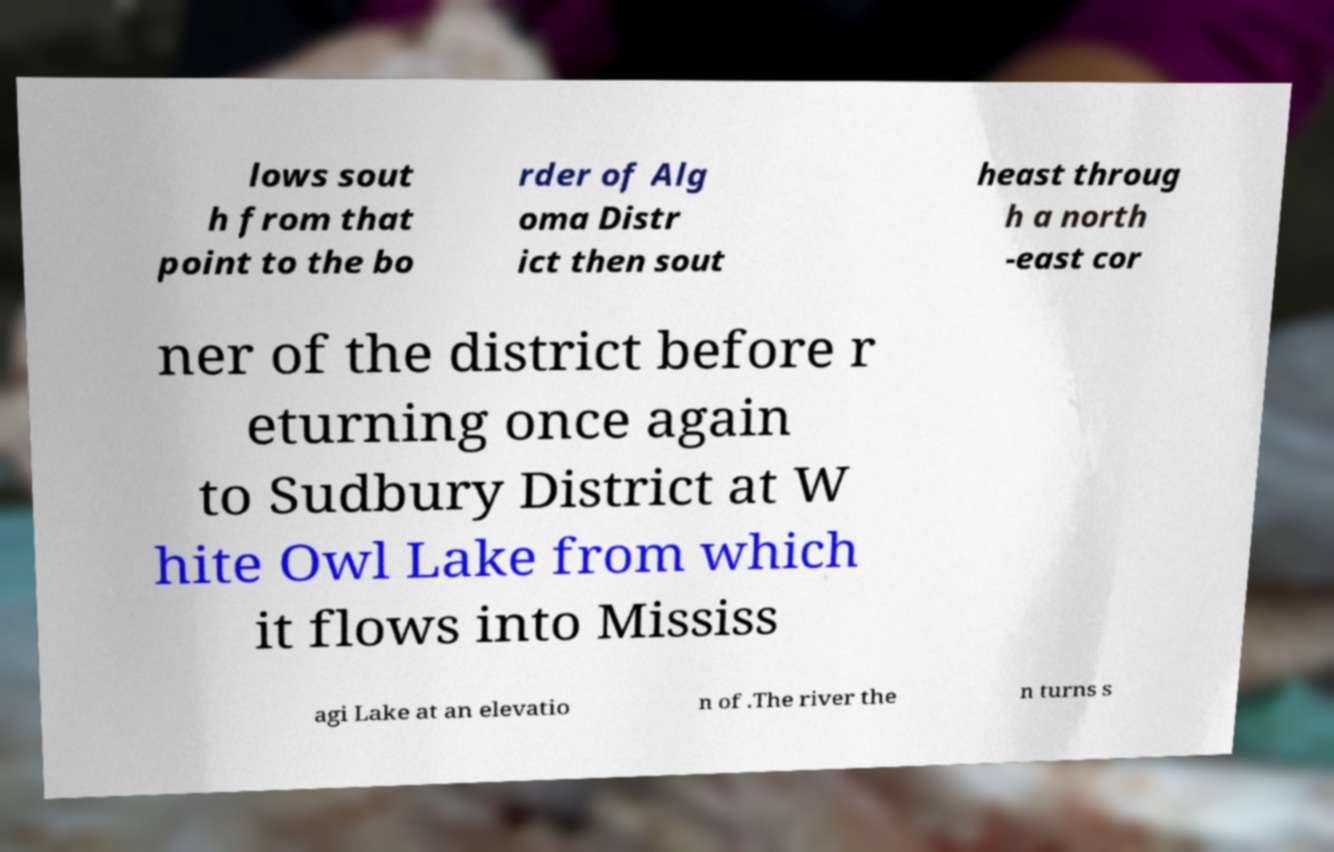Can you accurately transcribe the text from the provided image for me? lows sout h from that point to the bo rder of Alg oma Distr ict then sout heast throug h a north -east cor ner of the district before r eturning once again to Sudbury District at W hite Owl Lake from which it flows into Mississ agi Lake at an elevatio n of .The river the n turns s 